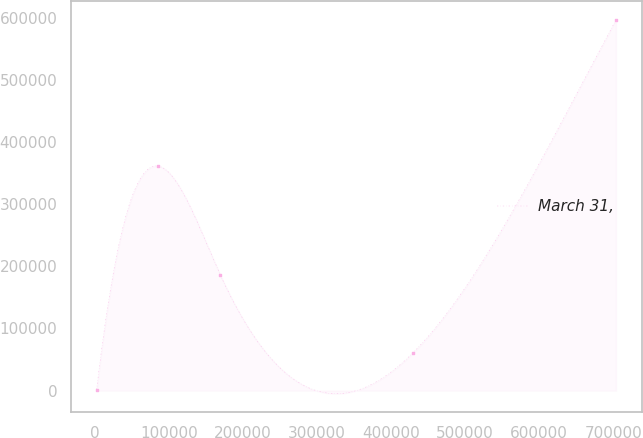<chart> <loc_0><loc_0><loc_500><loc_500><line_chart><ecel><fcel>March 31,<nl><fcel>1873.69<fcel>1631.69<nl><fcel>84954.3<fcel>361454<nl><fcel>169241<fcel>185687<nl><fcel>429575<fcel>61140.9<nl><fcel>703730<fcel>596724<nl></chart> 